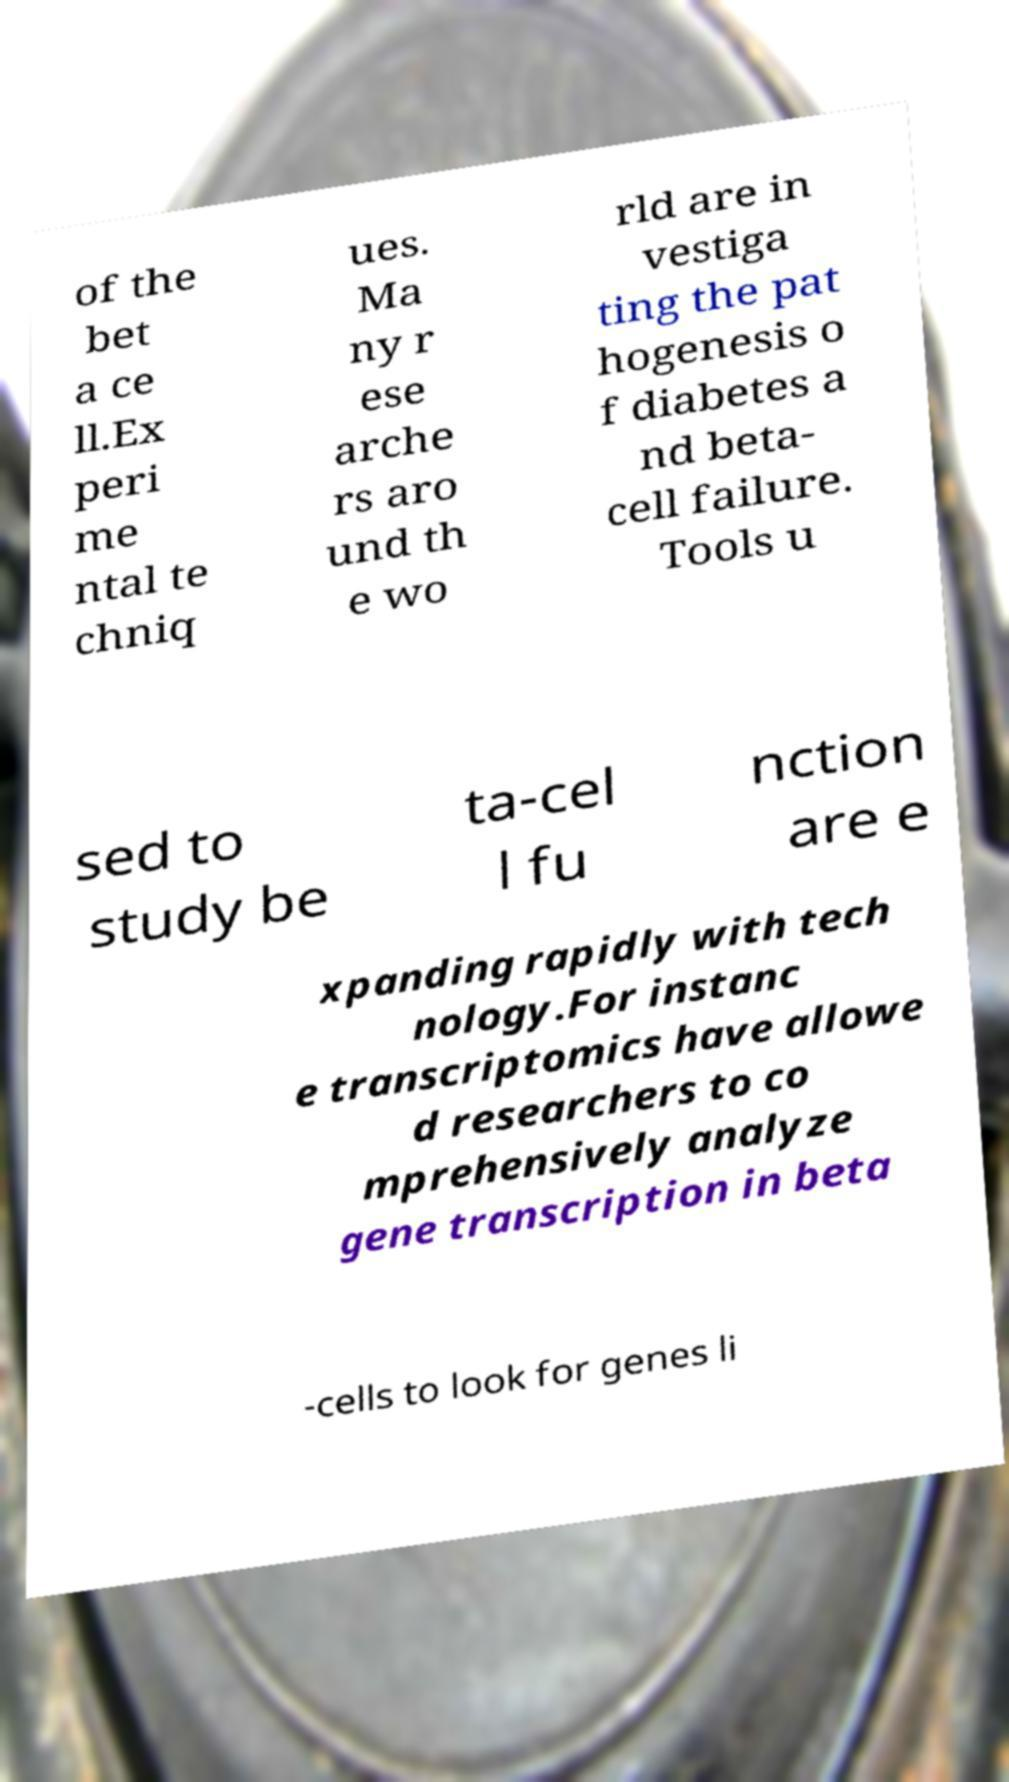Could you assist in decoding the text presented in this image and type it out clearly? of the bet a ce ll.Ex peri me ntal te chniq ues. Ma ny r ese arche rs aro und th e wo rld are in vestiga ting the pat hogenesis o f diabetes a nd beta- cell failure. Tools u sed to study be ta-cel l fu nction are e xpanding rapidly with tech nology.For instanc e transcriptomics have allowe d researchers to co mprehensively analyze gene transcription in beta -cells to look for genes li 